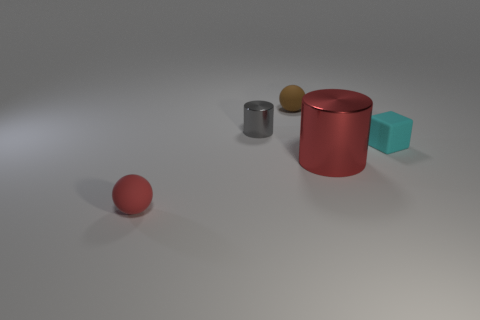There is a red object that is the same shape as the brown object; what size is it?
Your response must be concise. Small. Is there anything else that has the same size as the red cylinder?
Your response must be concise. No. There is a cylinder that is in front of the thing that is right of the red shiny thing; what is it made of?
Ensure brevity in your answer.  Metal. Is the small brown matte thing the same shape as the red rubber object?
Give a very brief answer. Yes. How many tiny rubber objects are both in front of the brown matte ball and behind the large red cylinder?
Keep it short and to the point. 1. Are there an equal number of big cylinders right of the red ball and big metal things to the left of the gray metal thing?
Ensure brevity in your answer.  No. Does the matte sphere behind the red cylinder have the same size as the thing that is in front of the big red cylinder?
Offer a very short reply. Yes. There is a object that is in front of the small cyan matte thing and right of the tiny gray metal thing; what is its material?
Your response must be concise. Metal. Is the number of cyan matte objects less than the number of cyan rubber cylinders?
Make the answer very short. No. How big is the shiny cylinder on the right side of the matte sphere that is behind the tiny red rubber ball?
Your response must be concise. Large. 